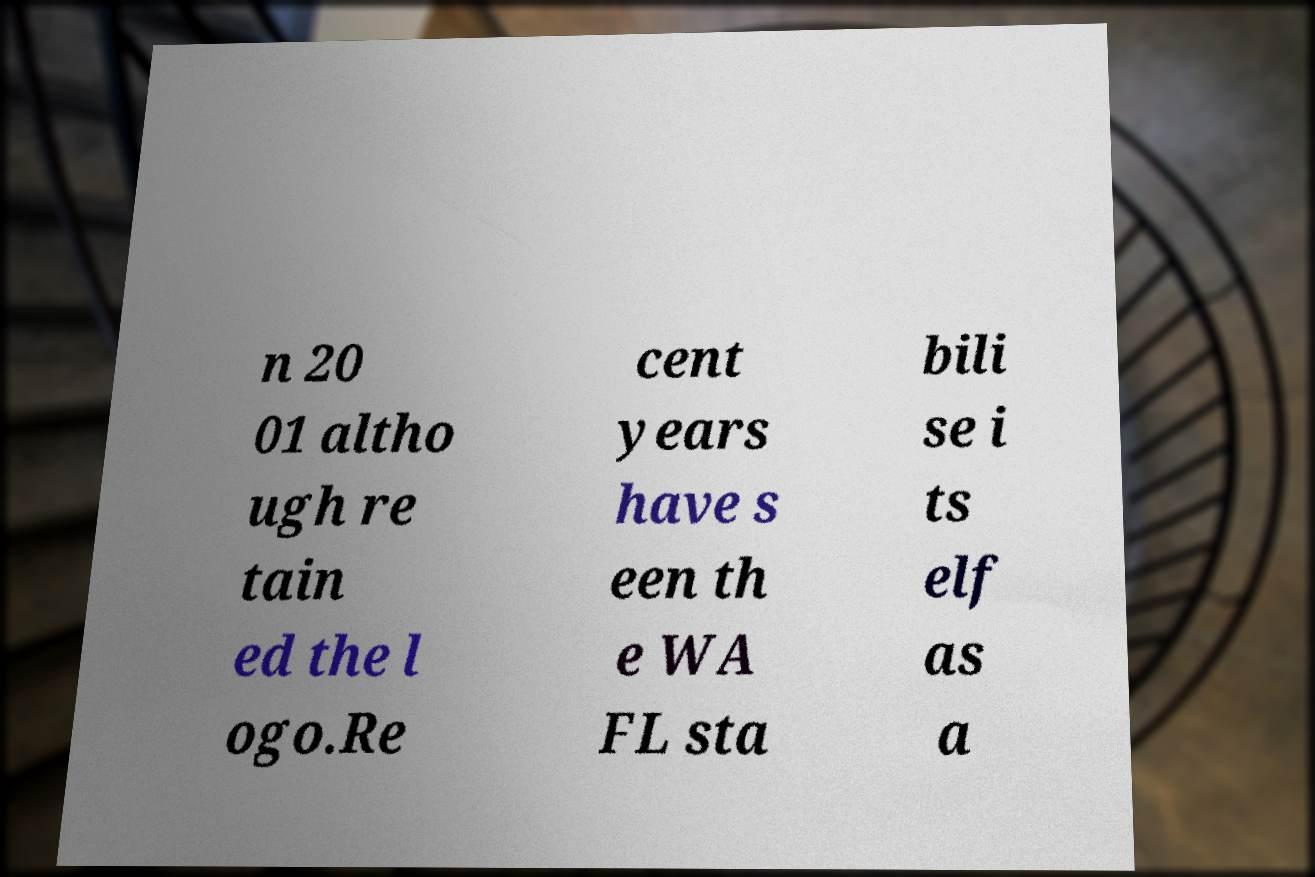Please read and relay the text visible in this image. What does it say? n 20 01 altho ugh re tain ed the l ogo.Re cent years have s een th e WA FL sta bili se i ts elf as a 